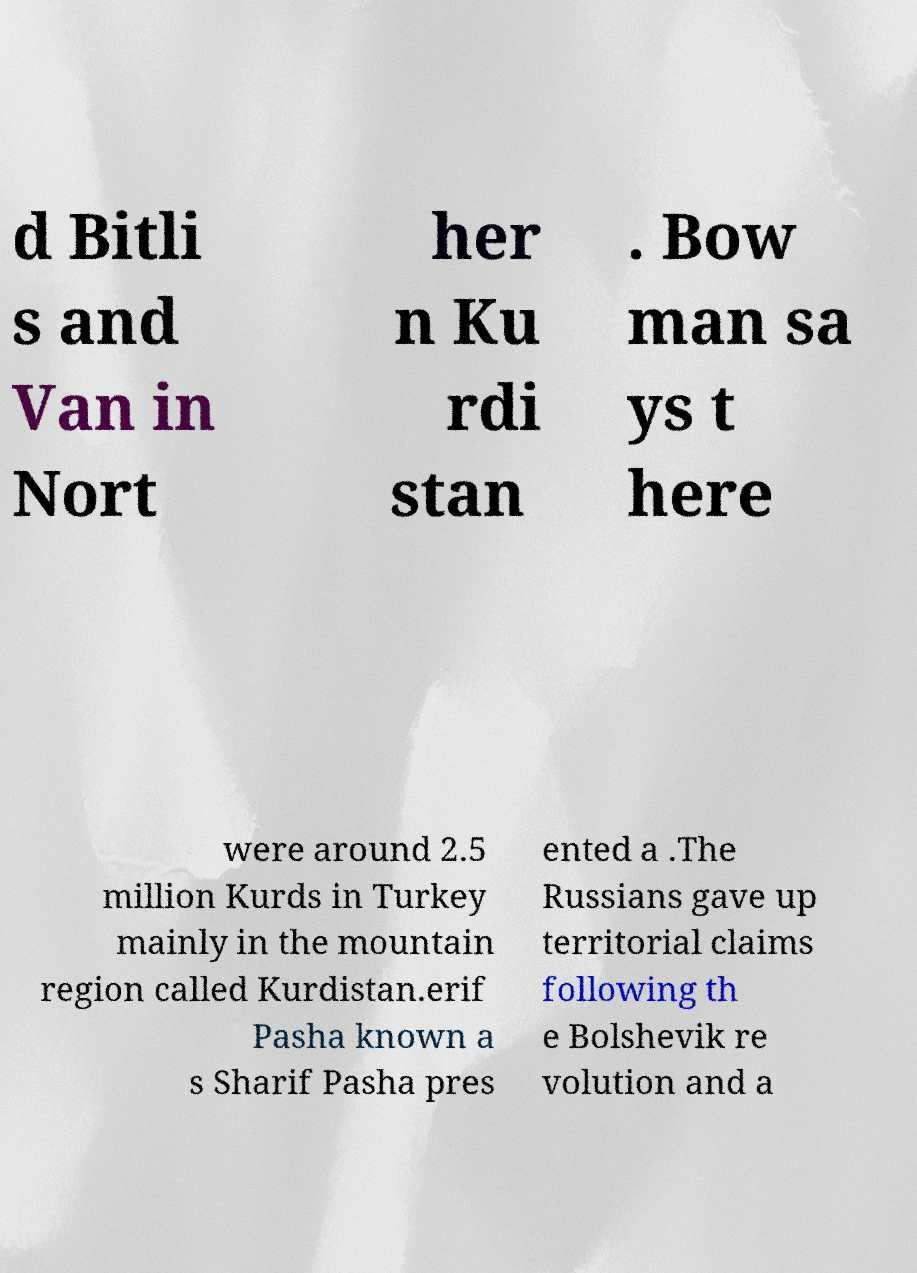Please identify and transcribe the text found in this image. d Bitli s and Van in Nort her n Ku rdi stan . Bow man sa ys t here were around 2.5 million Kurds in Turkey mainly in the mountain region called Kurdistan.erif Pasha known a s Sharif Pasha pres ented a .The Russians gave up territorial claims following th e Bolshevik re volution and a 